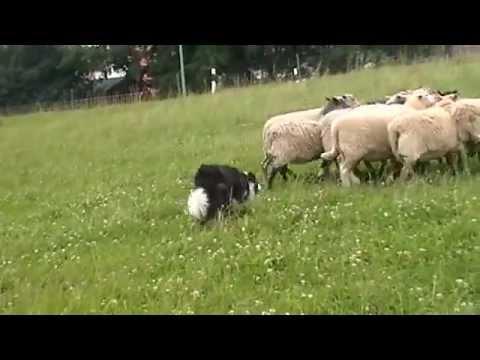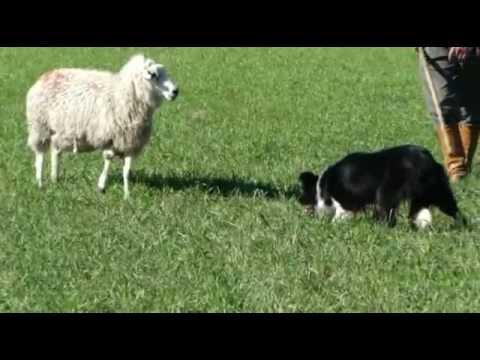The first image is the image on the left, the second image is the image on the right. Assess this claim about the two images: "An image includes a person with just one dog.". Correct or not? Answer yes or no. Yes. The first image is the image on the left, the second image is the image on the right. For the images displayed, is the sentence "In one image, a man is standing in a green, grassy area with multiple dogs and multiple sheep." factually correct? Answer yes or no. No. 